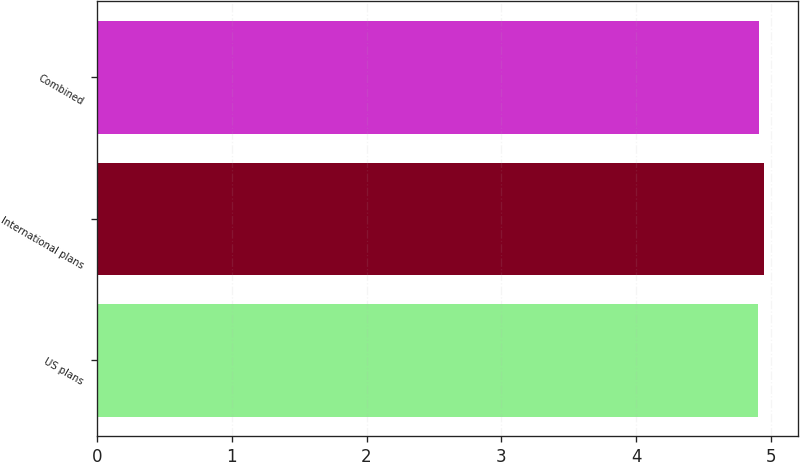Convert chart. <chart><loc_0><loc_0><loc_500><loc_500><bar_chart><fcel>US plans<fcel>International plans<fcel>Combined<nl><fcel>4.9<fcel>4.95<fcel>4.91<nl></chart> 